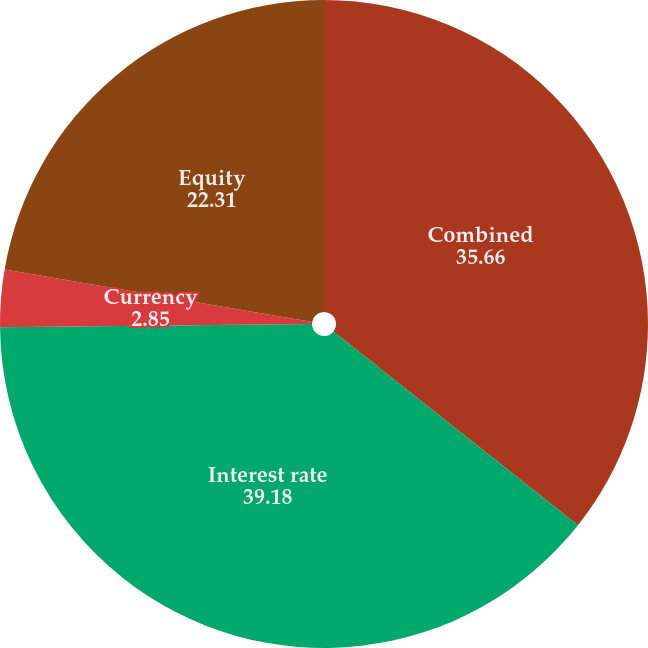<chart> <loc_0><loc_0><loc_500><loc_500><pie_chart><fcel>Combined<fcel>Interest rate<fcel>Currency<fcel>Equity<nl><fcel>35.66%<fcel>39.18%<fcel>2.85%<fcel>22.31%<nl></chart> 